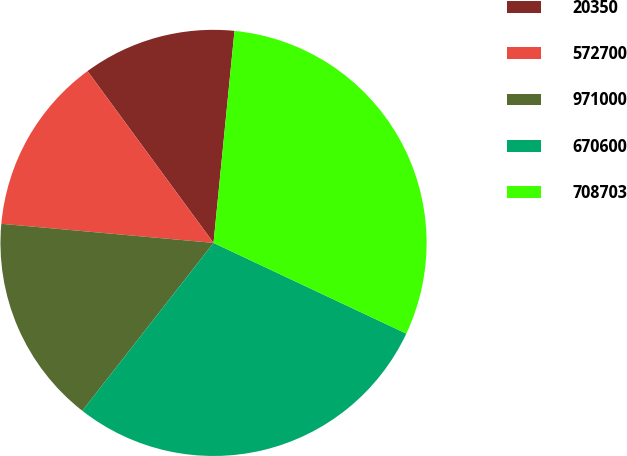Convert chart to OTSL. <chart><loc_0><loc_0><loc_500><loc_500><pie_chart><fcel>20350<fcel>572700<fcel>971000<fcel>670600<fcel>708703<nl><fcel>11.64%<fcel>13.5%<fcel>15.87%<fcel>28.56%<fcel>30.43%<nl></chart> 